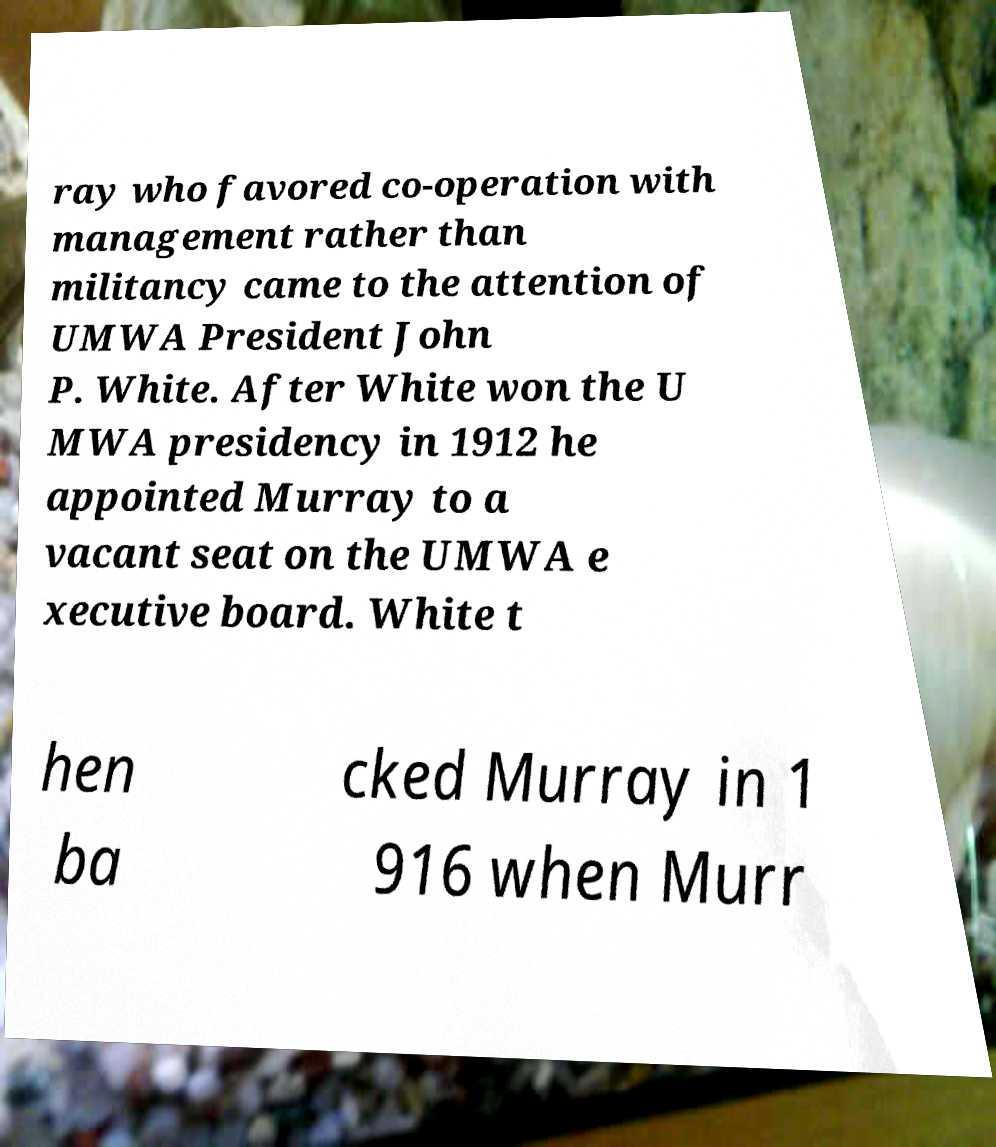Please identify and transcribe the text found in this image. ray who favored co-operation with management rather than militancy came to the attention of UMWA President John P. White. After White won the U MWA presidency in 1912 he appointed Murray to a vacant seat on the UMWA e xecutive board. White t hen ba cked Murray in 1 916 when Murr 